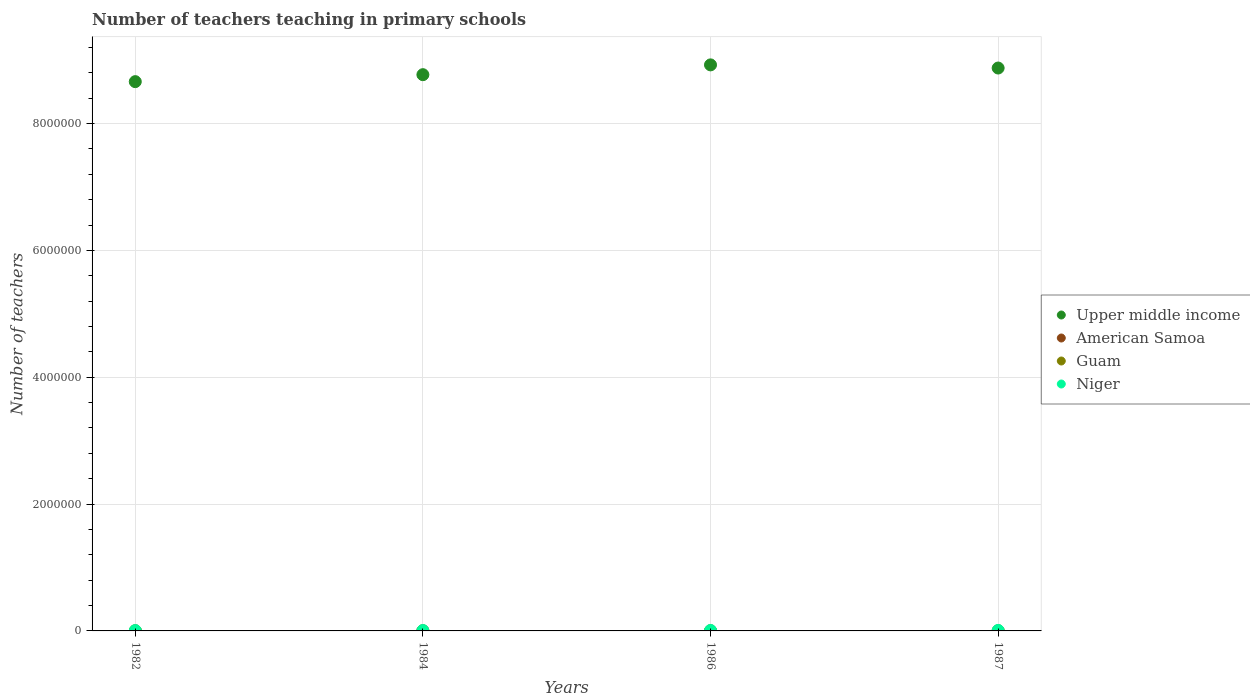How many different coloured dotlines are there?
Give a very brief answer. 4. Is the number of dotlines equal to the number of legend labels?
Offer a very short reply. Yes. What is the number of teachers teaching in primary schools in Niger in 1987?
Your response must be concise. 7690. Across all years, what is the maximum number of teachers teaching in primary schools in Guam?
Your answer should be very brief. 900. Across all years, what is the minimum number of teachers teaching in primary schools in Upper middle income?
Offer a terse response. 8.66e+06. What is the total number of teachers teaching in primary schools in Niger in the graph?
Give a very brief answer. 2.70e+04. What is the difference between the number of teachers teaching in primary schools in Guam in 1986 and that in 1987?
Your response must be concise. 0. What is the difference between the number of teachers teaching in primary schools in American Samoa in 1984 and the number of teachers teaching in primary schools in Guam in 1986?
Offer a terse response. -494. What is the average number of teachers teaching in primary schools in American Samoa per year?
Keep it short and to the point. 414.5. In the year 1984, what is the difference between the number of teachers teaching in primary schools in American Samoa and number of teachers teaching in primary schools in Niger?
Ensure brevity in your answer.  -5981. In how many years, is the number of teachers teaching in primary schools in Upper middle income greater than 3200000?
Your answer should be very brief. 4. What is the ratio of the number of teachers teaching in primary schools in Niger in 1986 to that in 1987?
Offer a very short reply. 0.96. Is the number of teachers teaching in primary schools in Niger in 1984 less than that in 1987?
Your response must be concise. Yes. What is the difference between the highest and the second highest number of teachers teaching in primary schools in Upper middle income?
Give a very brief answer. 4.97e+04. What is the difference between the highest and the lowest number of teachers teaching in primary schools in Upper middle income?
Offer a terse response. 2.64e+05. Is the sum of the number of teachers teaching in primary schools in Guam in 1982 and 1987 greater than the maximum number of teachers teaching in primary schools in Niger across all years?
Ensure brevity in your answer.  No. Is it the case that in every year, the sum of the number of teachers teaching in primary schools in American Samoa and number of teachers teaching in primary schools in Upper middle income  is greater than the number of teachers teaching in primary schools in Niger?
Offer a terse response. Yes. Does the number of teachers teaching in primary schools in American Samoa monotonically increase over the years?
Provide a succinct answer. No. Is the number of teachers teaching in primary schools in American Samoa strictly less than the number of teachers teaching in primary schools in Niger over the years?
Give a very brief answer. Yes. How many dotlines are there?
Your response must be concise. 4. How many years are there in the graph?
Ensure brevity in your answer.  4. Does the graph contain any zero values?
Your answer should be very brief. No. Does the graph contain grids?
Offer a terse response. Yes. How many legend labels are there?
Your answer should be very brief. 4. What is the title of the graph?
Your response must be concise. Number of teachers teaching in primary schools. Does "Argentina" appear as one of the legend labels in the graph?
Your answer should be compact. No. What is the label or title of the Y-axis?
Your answer should be very brief. Number of teachers. What is the Number of teachers in Upper middle income in 1982?
Provide a short and direct response. 8.66e+06. What is the Number of teachers in American Samoa in 1982?
Your answer should be compact. 395. What is the Number of teachers in Guam in 1982?
Offer a very short reply. 900. What is the Number of teachers in Niger in 1982?
Make the answer very short. 5608. What is the Number of teachers in Upper middle income in 1984?
Provide a short and direct response. 8.77e+06. What is the Number of teachers of American Samoa in 1984?
Offer a terse response. 346. What is the Number of teachers of Guam in 1984?
Provide a succinct answer. 870. What is the Number of teachers in Niger in 1984?
Ensure brevity in your answer.  6327. What is the Number of teachers of Upper middle income in 1986?
Keep it short and to the point. 8.92e+06. What is the Number of teachers of American Samoa in 1986?
Make the answer very short. 454. What is the Number of teachers in Guam in 1986?
Provide a short and direct response. 840. What is the Number of teachers of Niger in 1986?
Provide a succinct answer. 7383. What is the Number of teachers of Upper middle income in 1987?
Make the answer very short. 8.88e+06. What is the Number of teachers in American Samoa in 1987?
Offer a terse response. 463. What is the Number of teachers in Guam in 1987?
Provide a short and direct response. 840. What is the Number of teachers in Niger in 1987?
Give a very brief answer. 7690. Across all years, what is the maximum Number of teachers in Upper middle income?
Your response must be concise. 8.92e+06. Across all years, what is the maximum Number of teachers of American Samoa?
Keep it short and to the point. 463. Across all years, what is the maximum Number of teachers of Guam?
Provide a short and direct response. 900. Across all years, what is the maximum Number of teachers in Niger?
Your response must be concise. 7690. Across all years, what is the minimum Number of teachers of Upper middle income?
Make the answer very short. 8.66e+06. Across all years, what is the minimum Number of teachers in American Samoa?
Give a very brief answer. 346. Across all years, what is the minimum Number of teachers of Guam?
Provide a succinct answer. 840. Across all years, what is the minimum Number of teachers in Niger?
Keep it short and to the point. 5608. What is the total Number of teachers in Upper middle income in the graph?
Provide a succinct answer. 3.52e+07. What is the total Number of teachers of American Samoa in the graph?
Give a very brief answer. 1658. What is the total Number of teachers of Guam in the graph?
Keep it short and to the point. 3450. What is the total Number of teachers in Niger in the graph?
Give a very brief answer. 2.70e+04. What is the difference between the Number of teachers in Upper middle income in 1982 and that in 1984?
Provide a short and direct response. -1.10e+05. What is the difference between the Number of teachers of Niger in 1982 and that in 1984?
Ensure brevity in your answer.  -719. What is the difference between the Number of teachers of Upper middle income in 1982 and that in 1986?
Make the answer very short. -2.64e+05. What is the difference between the Number of teachers of American Samoa in 1982 and that in 1986?
Provide a short and direct response. -59. What is the difference between the Number of teachers in Guam in 1982 and that in 1986?
Offer a very short reply. 60. What is the difference between the Number of teachers of Niger in 1982 and that in 1986?
Your answer should be very brief. -1775. What is the difference between the Number of teachers of Upper middle income in 1982 and that in 1987?
Ensure brevity in your answer.  -2.15e+05. What is the difference between the Number of teachers in American Samoa in 1982 and that in 1987?
Your response must be concise. -68. What is the difference between the Number of teachers of Niger in 1982 and that in 1987?
Ensure brevity in your answer.  -2082. What is the difference between the Number of teachers of Upper middle income in 1984 and that in 1986?
Your response must be concise. -1.55e+05. What is the difference between the Number of teachers of American Samoa in 1984 and that in 1986?
Offer a terse response. -108. What is the difference between the Number of teachers in Guam in 1984 and that in 1986?
Keep it short and to the point. 30. What is the difference between the Number of teachers of Niger in 1984 and that in 1986?
Give a very brief answer. -1056. What is the difference between the Number of teachers of Upper middle income in 1984 and that in 1987?
Give a very brief answer. -1.05e+05. What is the difference between the Number of teachers in American Samoa in 1984 and that in 1987?
Ensure brevity in your answer.  -117. What is the difference between the Number of teachers of Niger in 1984 and that in 1987?
Keep it short and to the point. -1363. What is the difference between the Number of teachers of Upper middle income in 1986 and that in 1987?
Provide a succinct answer. 4.97e+04. What is the difference between the Number of teachers of American Samoa in 1986 and that in 1987?
Ensure brevity in your answer.  -9. What is the difference between the Number of teachers of Guam in 1986 and that in 1987?
Give a very brief answer. 0. What is the difference between the Number of teachers in Niger in 1986 and that in 1987?
Your answer should be very brief. -307. What is the difference between the Number of teachers of Upper middle income in 1982 and the Number of teachers of American Samoa in 1984?
Give a very brief answer. 8.66e+06. What is the difference between the Number of teachers in Upper middle income in 1982 and the Number of teachers in Guam in 1984?
Make the answer very short. 8.66e+06. What is the difference between the Number of teachers in Upper middle income in 1982 and the Number of teachers in Niger in 1984?
Offer a terse response. 8.65e+06. What is the difference between the Number of teachers of American Samoa in 1982 and the Number of teachers of Guam in 1984?
Offer a very short reply. -475. What is the difference between the Number of teachers in American Samoa in 1982 and the Number of teachers in Niger in 1984?
Keep it short and to the point. -5932. What is the difference between the Number of teachers of Guam in 1982 and the Number of teachers of Niger in 1984?
Keep it short and to the point. -5427. What is the difference between the Number of teachers in Upper middle income in 1982 and the Number of teachers in American Samoa in 1986?
Your answer should be very brief. 8.66e+06. What is the difference between the Number of teachers in Upper middle income in 1982 and the Number of teachers in Guam in 1986?
Offer a very short reply. 8.66e+06. What is the difference between the Number of teachers of Upper middle income in 1982 and the Number of teachers of Niger in 1986?
Make the answer very short. 8.65e+06. What is the difference between the Number of teachers of American Samoa in 1982 and the Number of teachers of Guam in 1986?
Provide a short and direct response. -445. What is the difference between the Number of teachers in American Samoa in 1982 and the Number of teachers in Niger in 1986?
Make the answer very short. -6988. What is the difference between the Number of teachers of Guam in 1982 and the Number of teachers of Niger in 1986?
Give a very brief answer. -6483. What is the difference between the Number of teachers of Upper middle income in 1982 and the Number of teachers of American Samoa in 1987?
Ensure brevity in your answer.  8.66e+06. What is the difference between the Number of teachers of Upper middle income in 1982 and the Number of teachers of Guam in 1987?
Provide a succinct answer. 8.66e+06. What is the difference between the Number of teachers of Upper middle income in 1982 and the Number of teachers of Niger in 1987?
Give a very brief answer. 8.65e+06. What is the difference between the Number of teachers of American Samoa in 1982 and the Number of teachers of Guam in 1987?
Offer a terse response. -445. What is the difference between the Number of teachers of American Samoa in 1982 and the Number of teachers of Niger in 1987?
Give a very brief answer. -7295. What is the difference between the Number of teachers in Guam in 1982 and the Number of teachers in Niger in 1987?
Provide a succinct answer. -6790. What is the difference between the Number of teachers of Upper middle income in 1984 and the Number of teachers of American Samoa in 1986?
Offer a terse response. 8.77e+06. What is the difference between the Number of teachers of Upper middle income in 1984 and the Number of teachers of Guam in 1986?
Your answer should be compact. 8.77e+06. What is the difference between the Number of teachers of Upper middle income in 1984 and the Number of teachers of Niger in 1986?
Give a very brief answer. 8.76e+06. What is the difference between the Number of teachers of American Samoa in 1984 and the Number of teachers of Guam in 1986?
Make the answer very short. -494. What is the difference between the Number of teachers in American Samoa in 1984 and the Number of teachers in Niger in 1986?
Ensure brevity in your answer.  -7037. What is the difference between the Number of teachers in Guam in 1984 and the Number of teachers in Niger in 1986?
Ensure brevity in your answer.  -6513. What is the difference between the Number of teachers of Upper middle income in 1984 and the Number of teachers of American Samoa in 1987?
Your answer should be very brief. 8.77e+06. What is the difference between the Number of teachers of Upper middle income in 1984 and the Number of teachers of Guam in 1987?
Make the answer very short. 8.77e+06. What is the difference between the Number of teachers in Upper middle income in 1984 and the Number of teachers in Niger in 1987?
Ensure brevity in your answer.  8.76e+06. What is the difference between the Number of teachers in American Samoa in 1984 and the Number of teachers in Guam in 1987?
Give a very brief answer. -494. What is the difference between the Number of teachers of American Samoa in 1984 and the Number of teachers of Niger in 1987?
Offer a terse response. -7344. What is the difference between the Number of teachers in Guam in 1984 and the Number of teachers in Niger in 1987?
Ensure brevity in your answer.  -6820. What is the difference between the Number of teachers in Upper middle income in 1986 and the Number of teachers in American Samoa in 1987?
Provide a short and direct response. 8.92e+06. What is the difference between the Number of teachers in Upper middle income in 1986 and the Number of teachers in Guam in 1987?
Ensure brevity in your answer.  8.92e+06. What is the difference between the Number of teachers in Upper middle income in 1986 and the Number of teachers in Niger in 1987?
Provide a short and direct response. 8.92e+06. What is the difference between the Number of teachers in American Samoa in 1986 and the Number of teachers in Guam in 1987?
Offer a very short reply. -386. What is the difference between the Number of teachers of American Samoa in 1986 and the Number of teachers of Niger in 1987?
Offer a terse response. -7236. What is the difference between the Number of teachers in Guam in 1986 and the Number of teachers in Niger in 1987?
Provide a succinct answer. -6850. What is the average Number of teachers of Upper middle income per year?
Your response must be concise. 8.81e+06. What is the average Number of teachers of American Samoa per year?
Your answer should be compact. 414.5. What is the average Number of teachers of Guam per year?
Provide a succinct answer. 862.5. What is the average Number of teachers in Niger per year?
Make the answer very short. 6752. In the year 1982, what is the difference between the Number of teachers of Upper middle income and Number of teachers of American Samoa?
Provide a succinct answer. 8.66e+06. In the year 1982, what is the difference between the Number of teachers in Upper middle income and Number of teachers in Guam?
Your answer should be very brief. 8.66e+06. In the year 1982, what is the difference between the Number of teachers of Upper middle income and Number of teachers of Niger?
Give a very brief answer. 8.65e+06. In the year 1982, what is the difference between the Number of teachers of American Samoa and Number of teachers of Guam?
Give a very brief answer. -505. In the year 1982, what is the difference between the Number of teachers in American Samoa and Number of teachers in Niger?
Offer a very short reply. -5213. In the year 1982, what is the difference between the Number of teachers of Guam and Number of teachers of Niger?
Your answer should be compact. -4708. In the year 1984, what is the difference between the Number of teachers in Upper middle income and Number of teachers in American Samoa?
Ensure brevity in your answer.  8.77e+06. In the year 1984, what is the difference between the Number of teachers of Upper middle income and Number of teachers of Guam?
Ensure brevity in your answer.  8.77e+06. In the year 1984, what is the difference between the Number of teachers of Upper middle income and Number of teachers of Niger?
Your response must be concise. 8.76e+06. In the year 1984, what is the difference between the Number of teachers in American Samoa and Number of teachers in Guam?
Your answer should be compact. -524. In the year 1984, what is the difference between the Number of teachers of American Samoa and Number of teachers of Niger?
Your answer should be compact. -5981. In the year 1984, what is the difference between the Number of teachers in Guam and Number of teachers in Niger?
Provide a short and direct response. -5457. In the year 1986, what is the difference between the Number of teachers in Upper middle income and Number of teachers in American Samoa?
Keep it short and to the point. 8.92e+06. In the year 1986, what is the difference between the Number of teachers of Upper middle income and Number of teachers of Guam?
Provide a short and direct response. 8.92e+06. In the year 1986, what is the difference between the Number of teachers in Upper middle income and Number of teachers in Niger?
Offer a terse response. 8.92e+06. In the year 1986, what is the difference between the Number of teachers in American Samoa and Number of teachers in Guam?
Your answer should be compact. -386. In the year 1986, what is the difference between the Number of teachers in American Samoa and Number of teachers in Niger?
Offer a terse response. -6929. In the year 1986, what is the difference between the Number of teachers in Guam and Number of teachers in Niger?
Ensure brevity in your answer.  -6543. In the year 1987, what is the difference between the Number of teachers in Upper middle income and Number of teachers in American Samoa?
Give a very brief answer. 8.87e+06. In the year 1987, what is the difference between the Number of teachers of Upper middle income and Number of teachers of Guam?
Offer a very short reply. 8.87e+06. In the year 1987, what is the difference between the Number of teachers in Upper middle income and Number of teachers in Niger?
Offer a very short reply. 8.87e+06. In the year 1987, what is the difference between the Number of teachers of American Samoa and Number of teachers of Guam?
Keep it short and to the point. -377. In the year 1987, what is the difference between the Number of teachers of American Samoa and Number of teachers of Niger?
Keep it short and to the point. -7227. In the year 1987, what is the difference between the Number of teachers of Guam and Number of teachers of Niger?
Your response must be concise. -6850. What is the ratio of the Number of teachers in Upper middle income in 1982 to that in 1984?
Your answer should be compact. 0.99. What is the ratio of the Number of teachers in American Samoa in 1982 to that in 1984?
Offer a terse response. 1.14. What is the ratio of the Number of teachers of Guam in 1982 to that in 1984?
Offer a very short reply. 1.03. What is the ratio of the Number of teachers of Niger in 1982 to that in 1984?
Your answer should be very brief. 0.89. What is the ratio of the Number of teachers in Upper middle income in 1982 to that in 1986?
Your answer should be compact. 0.97. What is the ratio of the Number of teachers in American Samoa in 1982 to that in 1986?
Offer a terse response. 0.87. What is the ratio of the Number of teachers of Guam in 1982 to that in 1986?
Make the answer very short. 1.07. What is the ratio of the Number of teachers of Niger in 1982 to that in 1986?
Make the answer very short. 0.76. What is the ratio of the Number of teachers of Upper middle income in 1982 to that in 1987?
Offer a terse response. 0.98. What is the ratio of the Number of teachers of American Samoa in 1982 to that in 1987?
Offer a terse response. 0.85. What is the ratio of the Number of teachers of Guam in 1982 to that in 1987?
Your answer should be very brief. 1.07. What is the ratio of the Number of teachers of Niger in 1982 to that in 1987?
Provide a succinct answer. 0.73. What is the ratio of the Number of teachers of Upper middle income in 1984 to that in 1986?
Your response must be concise. 0.98. What is the ratio of the Number of teachers in American Samoa in 1984 to that in 1986?
Provide a succinct answer. 0.76. What is the ratio of the Number of teachers in Guam in 1984 to that in 1986?
Provide a short and direct response. 1.04. What is the ratio of the Number of teachers in Niger in 1984 to that in 1986?
Provide a succinct answer. 0.86. What is the ratio of the Number of teachers of American Samoa in 1984 to that in 1987?
Keep it short and to the point. 0.75. What is the ratio of the Number of teachers in Guam in 1984 to that in 1987?
Make the answer very short. 1.04. What is the ratio of the Number of teachers of Niger in 1984 to that in 1987?
Provide a short and direct response. 0.82. What is the ratio of the Number of teachers in Upper middle income in 1986 to that in 1987?
Offer a very short reply. 1.01. What is the ratio of the Number of teachers in American Samoa in 1986 to that in 1987?
Your response must be concise. 0.98. What is the ratio of the Number of teachers of Niger in 1986 to that in 1987?
Your response must be concise. 0.96. What is the difference between the highest and the second highest Number of teachers of Upper middle income?
Offer a terse response. 4.97e+04. What is the difference between the highest and the second highest Number of teachers of American Samoa?
Provide a succinct answer. 9. What is the difference between the highest and the second highest Number of teachers in Guam?
Keep it short and to the point. 30. What is the difference between the highest and the second highest Number of teachers in Niger?
Provide a succinct answer. 307. What is the difference between the highest and the lowest Number of teachers in Upper middle income?
Your answer should be compact. 2.64e+05. What is the difference between the highest and the lowest Number of teachers of American Samoa?
Make the answer very short. 117. What is the difference between the highest and the lowest Number of teachers in Guam?
Ensure brevity in your answer.  60. What is the difference between the highest and the lowest Number of teachers of Niger?
Ensure brevity in your answer.  2082. 